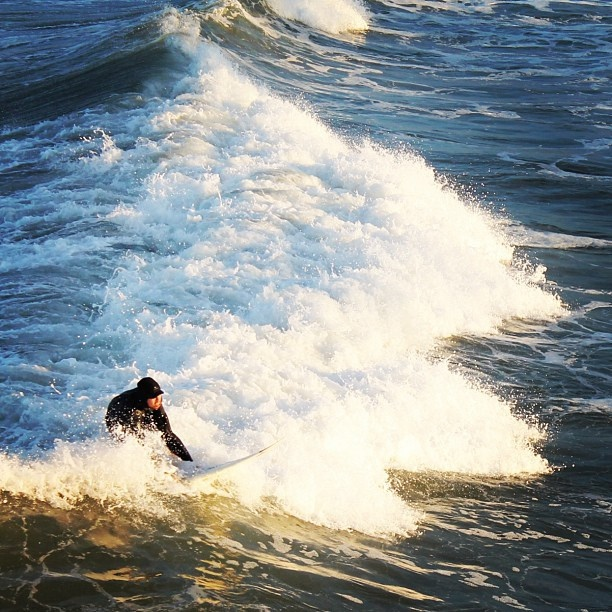Describe the objects in this image and their specific colors. I can see people in darkblue, black, lightgray, gray, and darkgray tones and surfboard in darkblue, darkgray, and lightgray tones in this image. 